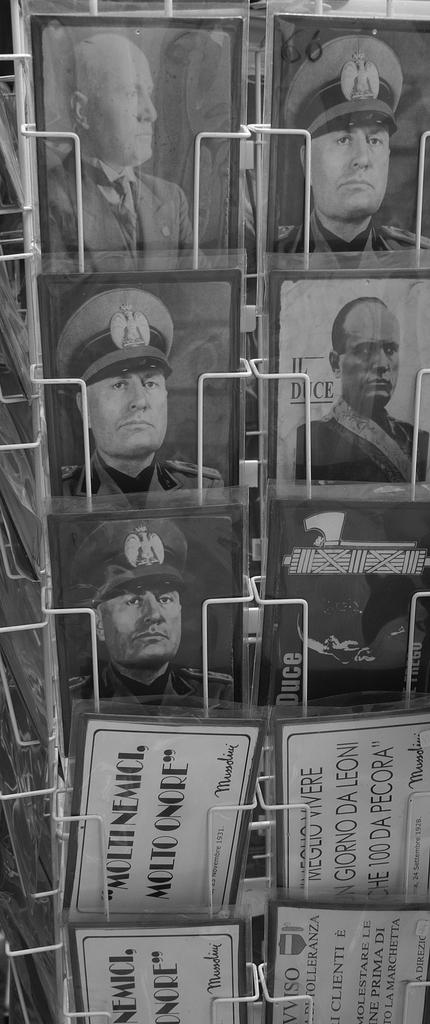Provide a one-sentence caption for the provided image. Photos of various men in black and white and signs saying Moltinemici Molto Onore and others. 